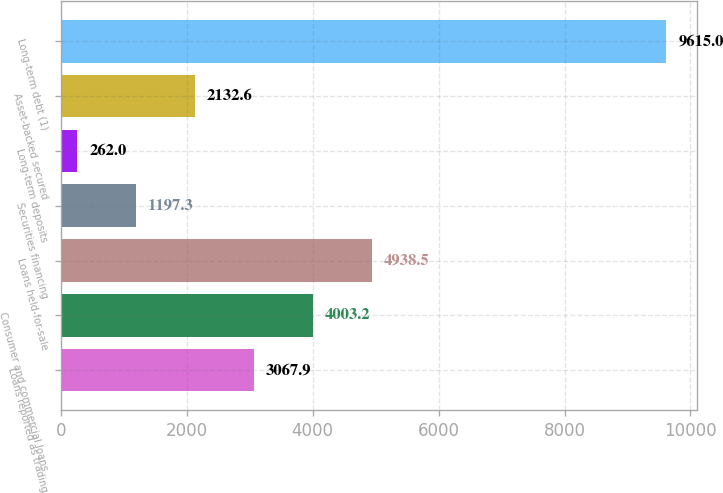Convert chart. <chart><loc_0><loc_0><loc_500><loc_500><bar_chart><fcel>Loans reported as trading<fcel>Consumer and commercial loans<fcel>Loans held-for-sale<fcel>Securities financing<fcel>Long-term deposits<fcel>Asset-backed secured<fcel>Long-term debt (1)<nl><fcel>3067.9<fcel>4003.2<fcel>4938.5<fcel>1197.3<fcel>262<fcel>2132.6<fcel>9615<nl></chart> 